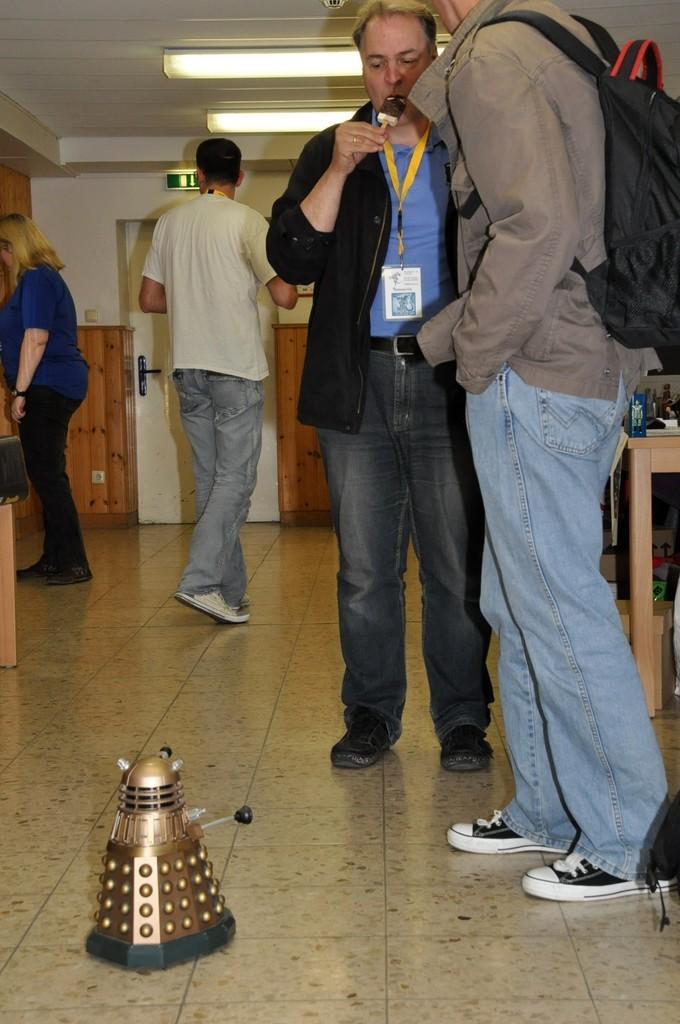Could you give a brief overview of what you see in this image? In this picture we can see four people and a toy on the floor and a man carrying a bag and in the background we can see the lights, wall, table and some objects. 